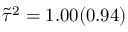Convert formula to latex. <formula><loc_0><loc_0><loc_500><loc_500>\tilde { \tau } ^ { 2 } = 1 . 0 0 ( 0 . 9 4 )</formula> 